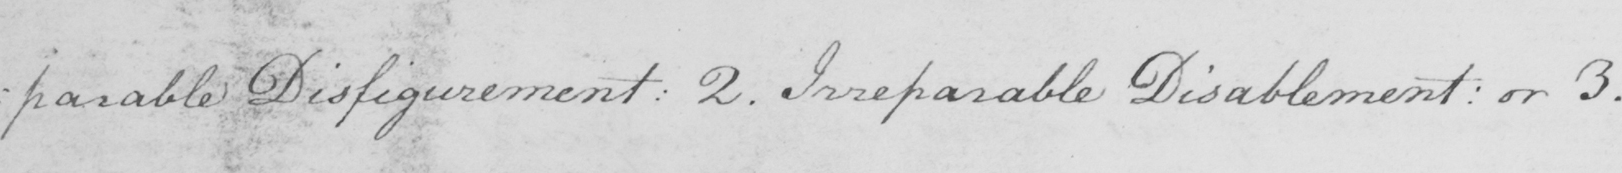Can you tell me what this handwritten text says? :parable Disfigurement: 2. Irreparable Disablement: or 3. 